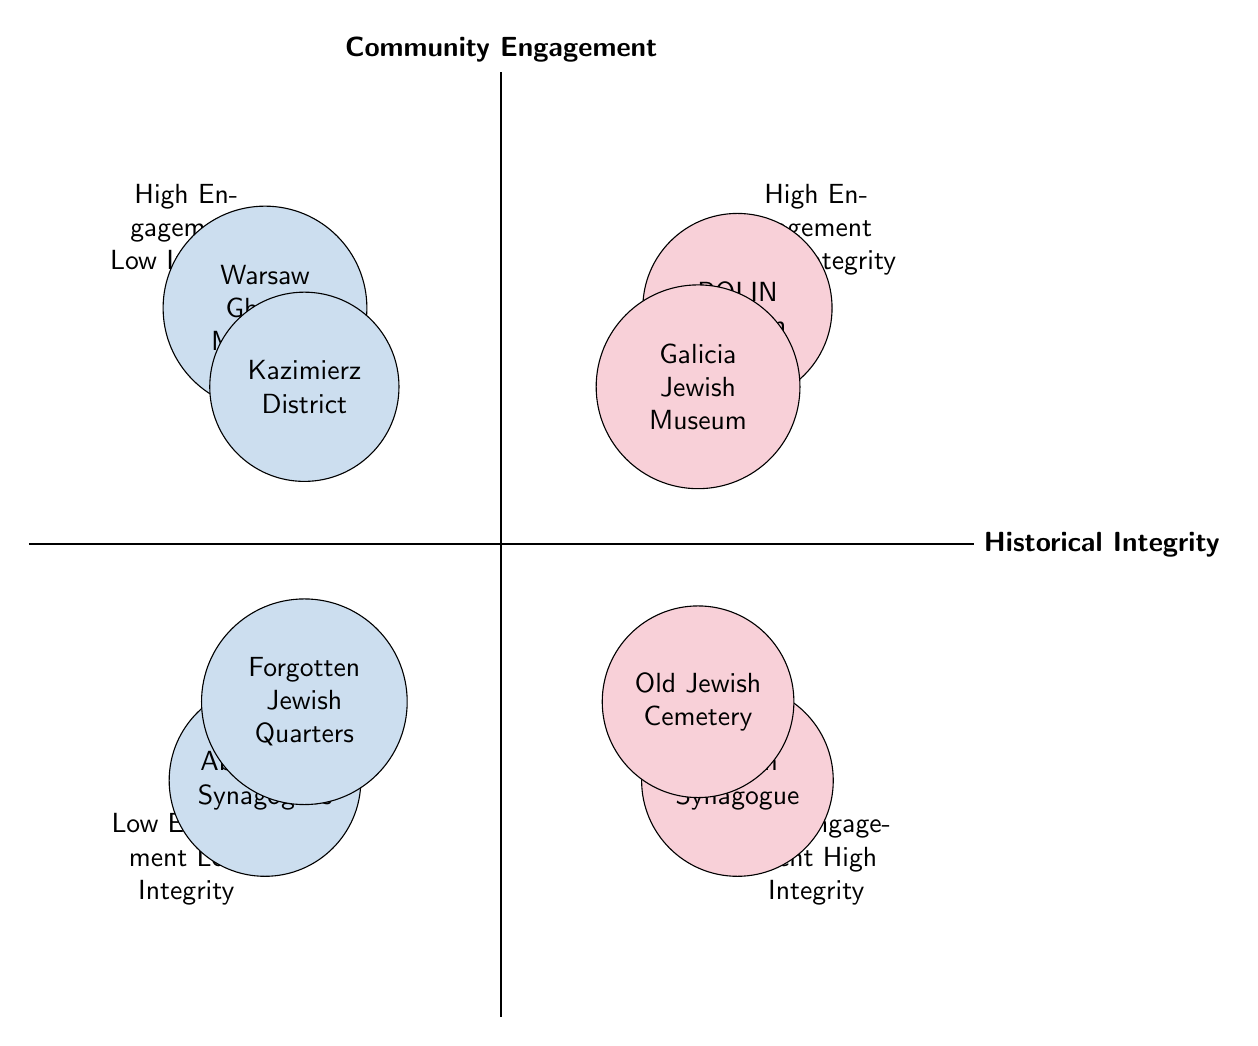What are the two Jewish heritage sites with high community engagement and high historical integrity? The top right quadrant of the chart lists the sites with both high community engagement and high historical integrity. They are the POLIN Museum of the History of Polish Jews and the Galicia Jewish Museum.
Answer: POLIN Museum of the History of Polish Jews, Galicia Jewish Museum Which Jewish heritage site is located in the low engagement and low integrity quadrant? The bottom left quadrant indicates low community engagement and low historical integrity. The sites listed here are the Abandoned Synagogues in Small Towns and Forgotten Jewish Quarters.
Answer: Abandoned Synagogues in Small Towns, Forgotten Jewish Quarters How many sites are in the high community engagement and low historical integrity quadrant? In the top left quadrant, there are two sites: the Warsaw Ghetto Memorial and Kazimierz District in Kraków. Counting these gives us a total of two sites in that quadrant.
Answer: 2 What is the characteristic of the site "Remuh Synagogue and Cemetery"? The site is located in the low community engagement and high historical integrity quadrant, known for being well-preserved with limited community activities. This indicates a strong historical integrity but low community involvement.
Answer: Well-preserved, limited activities Which quadrant contains both modern cultural events and historical artifacts? This description fits sites in the high community engagement and high historical integrity quadrant. The Galicia Jewish Museum is specifically mentioned for preserving artifacts while hosting modern events, indicating a balance of both aspects.
Answer: High Engagement High Integrity What types of activities are overshadowing the Warsaw Ghetto Memorial? The chart states that the Warsaw Ghetto Memorial features modern gatherings and public art installations, which overshadow its historical context, indicating an imbalance in engagement versus integrity.
Answer: Modern gatherings, public art installations 